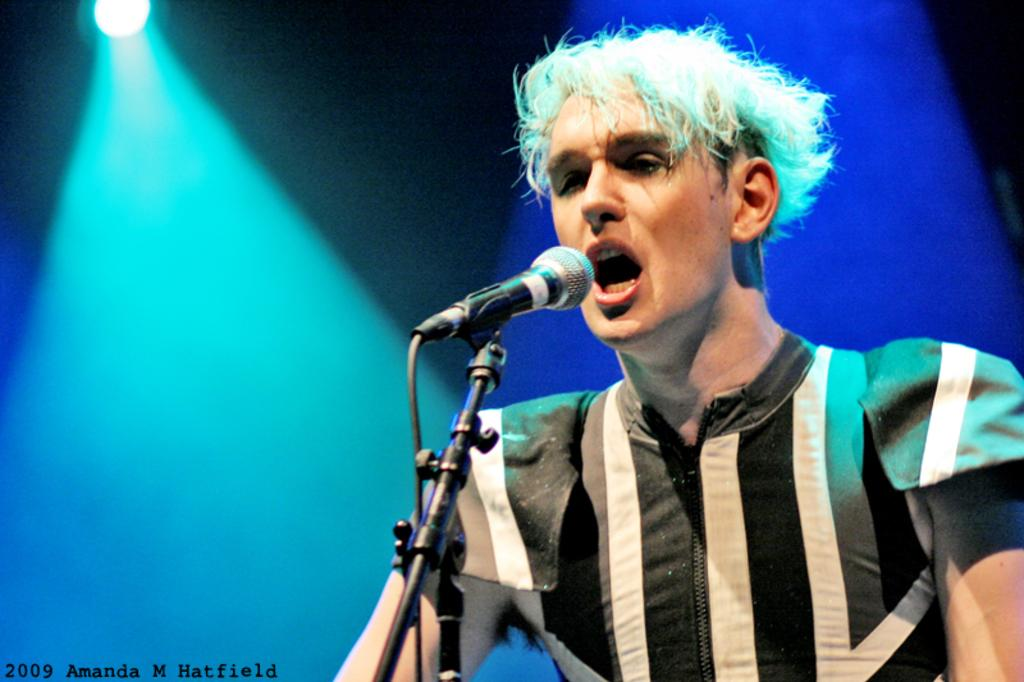What is the person in the image doing? The person is standing and singing in the image. What is the person holding or using while singing? There is a microphone on a stand in the image. What can be seen at the top of the image? There are lights visible at the top of the image. Where is the text located in the image? The text is present in the bottom left of the image. What type of plane is visible in the image? There is no plane present in the image. What kind of test is being conducted in the image? There is no test being conducted in the image; it features a person singing with a microphone. 